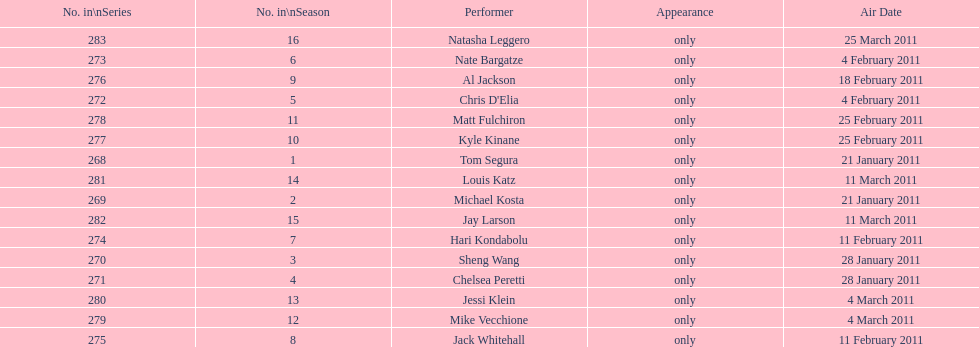What was hari's last name? Kondabolu. 